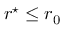Convert formula to latex. <formula><loc_0><loc_0><loc_500><loc_500>r ^ { ^ { * } } \leq r _ { 0 }</formula> 